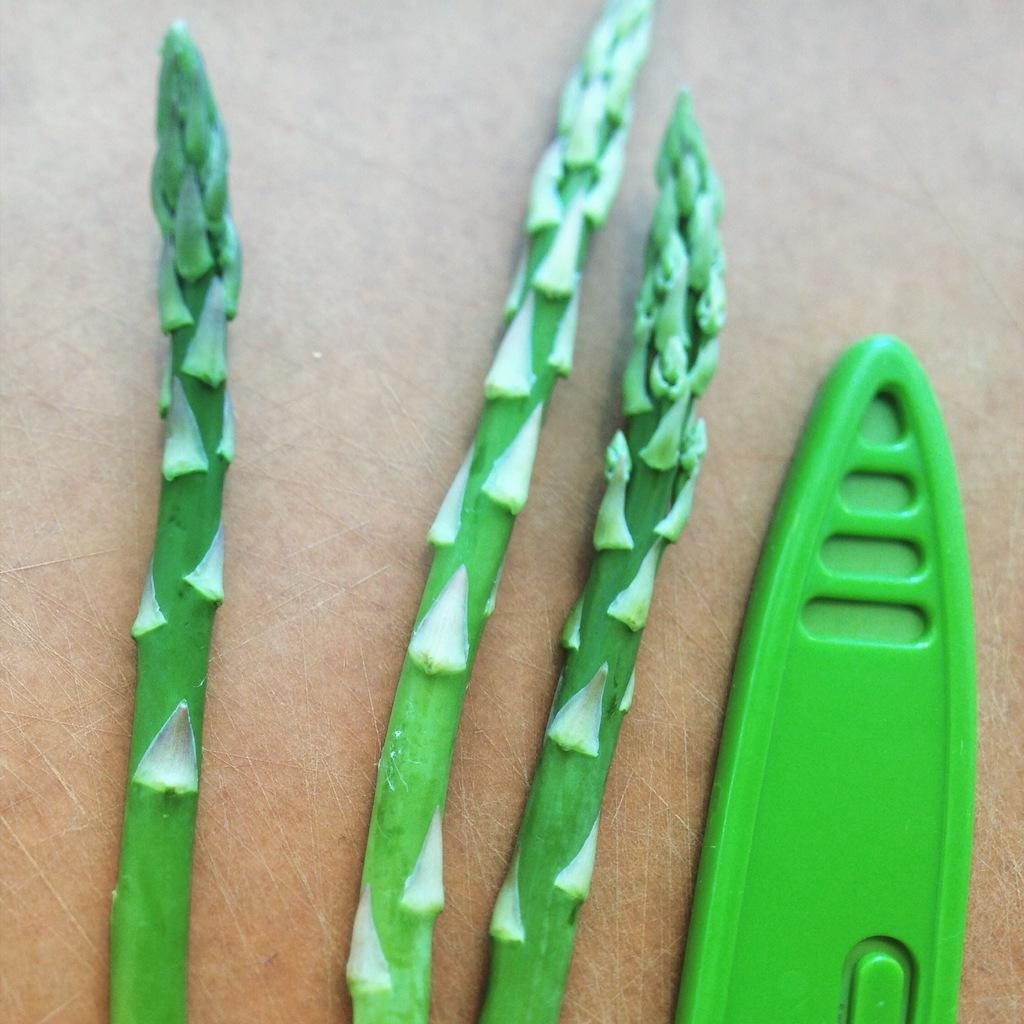What is located in the center of the image? There are green stems in the center of the image. What type of toy can be seen on the right side of the image? There is a toy surfing boat on the right side of the image. What type of riddle can be seen in the image? There is no riddle present in the image; it features green stems and a toy surfing boat. How many boats are in the yard in the image? There is no yard or additional boats present in the image. 